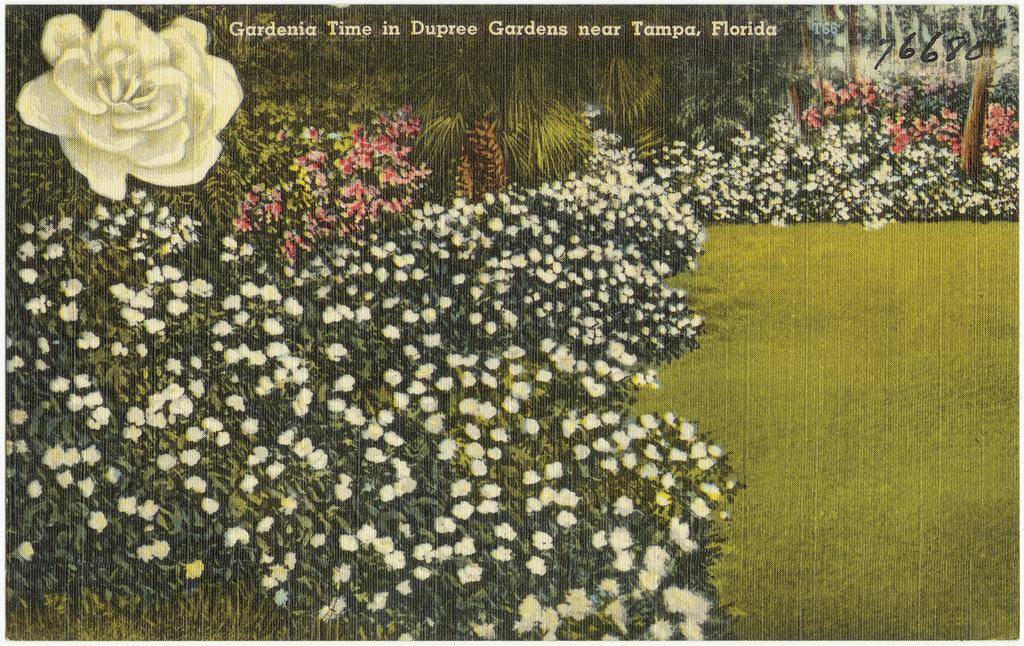What type of vegetation can be seen in the image? There are flower plants, trees, and grass in the image. What is written at the top of the image? There is text at the top of the image. What numbers are present at the top of the image? There are numbers at the top of the image. How many cows can be seen grazing on the grass in the image? There are no cows present in the image; it features flower plants, trees, and grass. What type of skin is visible on the seashore in the image? There is no seashore or skin visible in the image; it features text, numbers, and vegetation. 